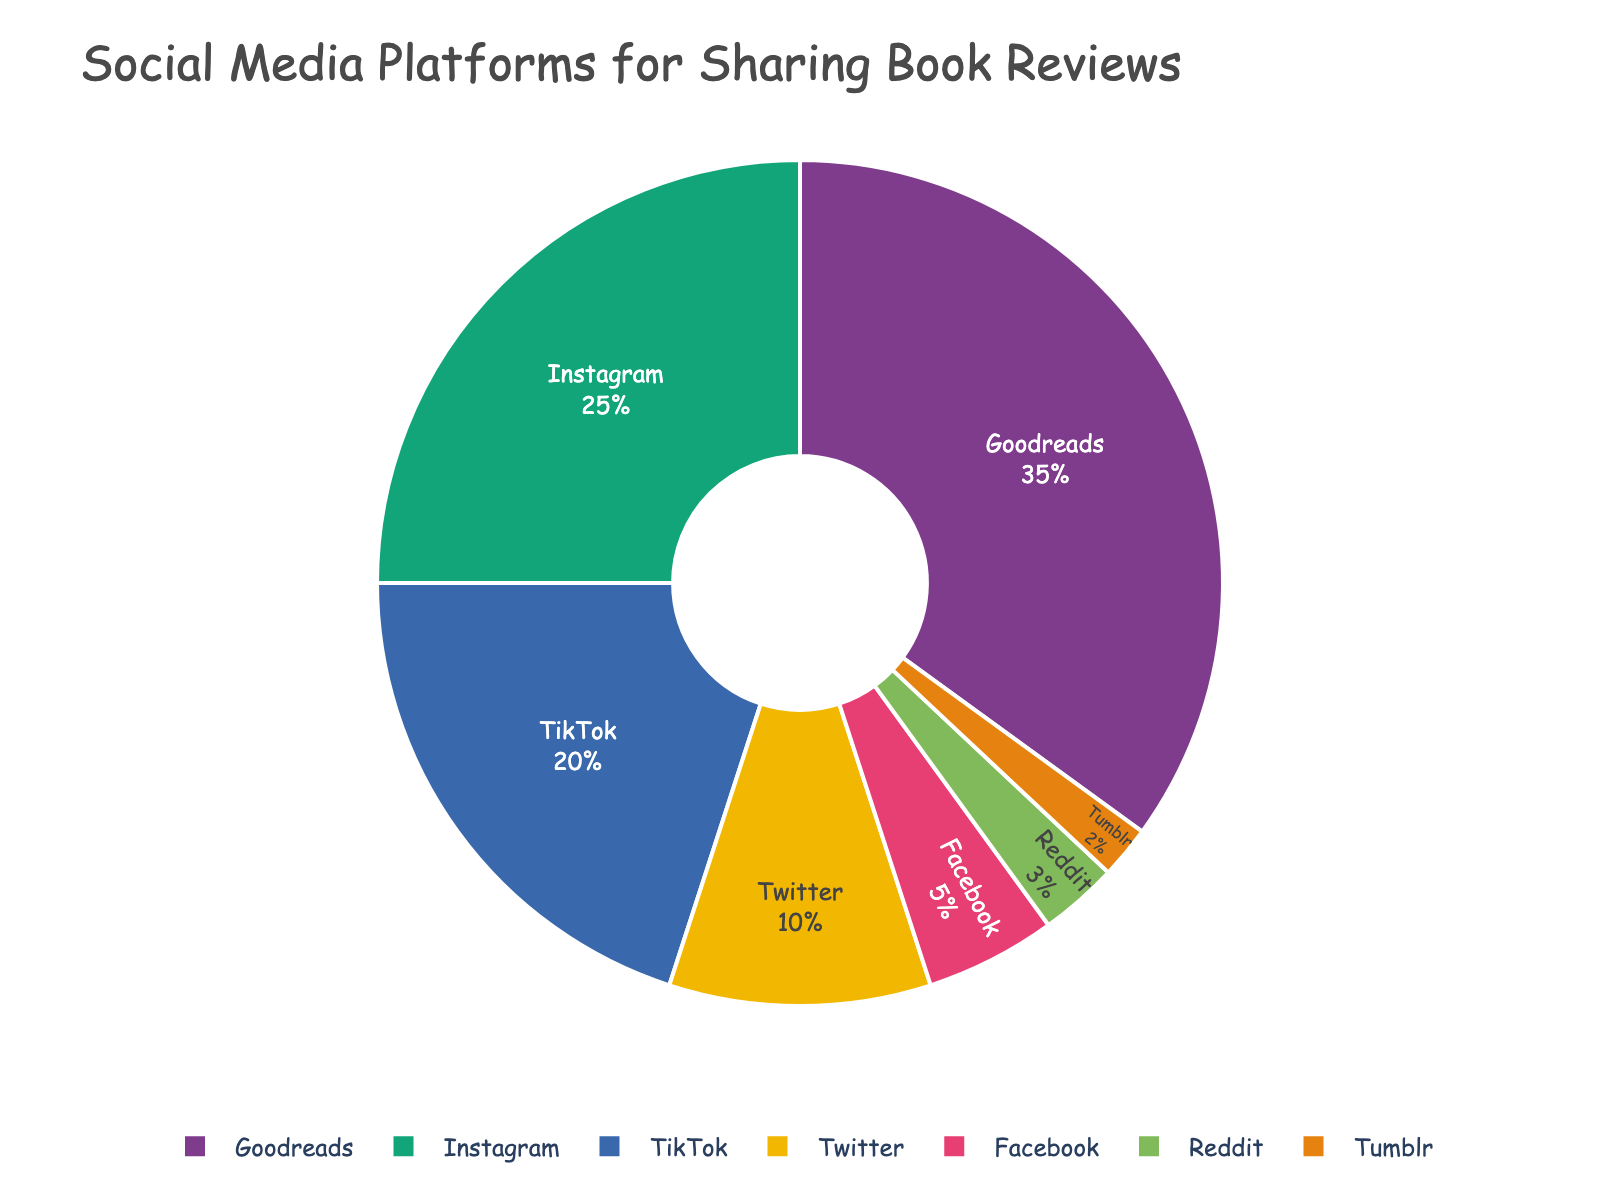what is the platform with the largest percentage in the pie chart? The platform with the largest percentage can be identified by looking at the slice of the pie chart that takes up the most space. From the data, it's clear that the largest portion of the pie is represented by Goodreads with 35%.
Answer: Goodreads How much larger is the percentage of TikTok compared to Twitter? From the pie chart, TikTok has a percentage of 20% while Twitter has 10%. The difference can be calculated by subtracting the percentage of Twitter from TikTok’s percentage: 20% - 10% = 10%.
Answer: 10% What is the combined percentage for Instagram and Facebook? To find the combined percentage for Instagram and Facebook, add their individual percentages together: 25% (Instagram) + 5% (Facebook) = 30%.
Answer: 30% Which platform has the smallest percentage, and what is it? Observing the pie chart, the smallest slice corresponds to Tumblr, with a percentage of 2%.
Answer: Tumblr, 2% Is the percentage of Goodreads more than double that of TikTok? To determine if Goodreads' percentage is more than double that of TikTok, calculate twice the percentage of TikTok (20% * 2 = 40%) and compare it with Goodreads’ 35%. Since 35% is less than 40%, Goodreads is not more than double that of TikTok.
Answer: No How does the percentage of Reddit compare to the combined percentage of Facebook and Tumblr? The percentage of Reddit is 3%. The combined percentage of Facebook and Tumblr is 5% (Facebook) + 2% (Tumblr) = 7%. Comparing them, 3% is less than 7%.
Answer: Reddit is less than the combined Facebook and Tumblr What percentage of the platforms together make up less than 10%? Summing up the percentages for the platforms with less than 10% each: Twitter (10%), Facebook (5%), Reddit (3%), and Tumblr (2%). Together, the sum is 10% + 5% + 3% + 2% = 20%.
Answer: 20% Which two platforms together make up the majority of the percentage? To find the majority, look for the smallest combination of platforms that added together exceed 50%. Goodreads (35%) + Instagram (25%) = 60%, which is more than 50%. These two make up the majority.
Answer: Goodreads and Instagram Which platforms are represented by a slice in a bold color? The pie chart’s color scheme uses bold colors for each platform. All platforms: Goodreads, Instagram, TikTok, Twitter, Facebook, Reddit, and Tumblr are in bold colors.
Answer: All platforms 